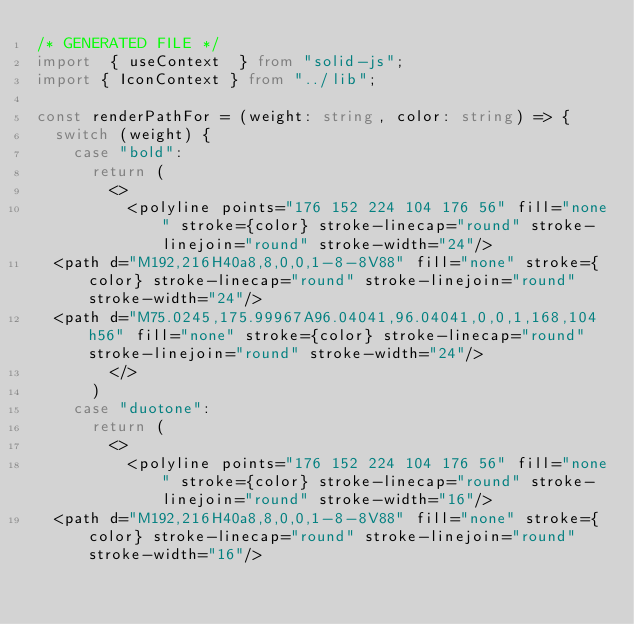<code> <loc_0><loc_0><loc_500><loc_500><_TypeScript_>/* GENERATED FILE */
import  { useContext  } from "solid-js";
import { IconContext } from "../lib";

const renderPathFor = (weight: string, color: string) => {
  switch (weight) {
    case "bold":
      return (
        <>
          <polyline points="176 152 224 104 176 56" fill="none" stroke={color} stroke-linecap="round" stroke-linejoin="round" stroke-width="24"/>
  <path d="M192,216H40a8,8,0,0,1-8-8V88" fill="none" stroke={color} stroke-linecap="round" stroke-linejoin="round" stroke-width="24"/>
  <path d="M75.0245,175.99967A96.04041,96.04041,0,0,1,168,104h56" fill="none" stroke={color} stroke-linecap="round" stroke-linejoin="round" stroke-width="24"/>
        </>
      )
    case "duotone":
      return (
        <>
          <polyline points="176 152 224 104 176 56" fill="none" stroke={color} stroke-linecap="round" stroke-linejoin="round" stroke-width="16"/>
  <path d="M192,216H40a8,8,0,0,1-8-8V88" fill="none" stroke={color} stroke-linecap="round" stroke-linejoin="round" stroke-width="16"/></code> 